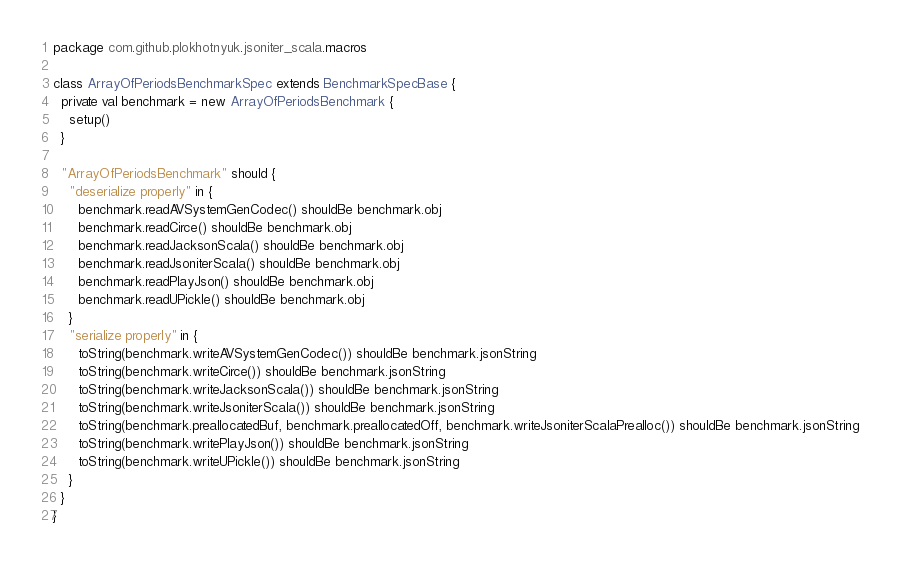<code> <loc_0><loc_0><loc_500><loc_500><_Scala_>package com.github.plokhotnyuk.jsoniter_scala.macros

class ArrayOfPeriodsBenchmarkSpec extends BenchmarkSpecBase {
  private val benchmark = new ArrayOfPeriodsBenchmark {
    setup()
  }
  
  "ArrayOfPeriodsBenchmark" should {
    "deserialize properly" in {
      benchmark.readAVSystemGenCodec() shouldBe benchmark.obj
      benchmark.readCirce() shouldBe benchmark.obj
      benchmark.readJacksonScala() shouldBe benchmark.obj
      benchmark.readJsoniterScala() shouldBe benchmark.obj
      benchmark.readPlayJson() shouldBe benchmark.obj
      benchmark.readUPickle() shouldBe benchmark.obj
    }
    "serialize properly" in {
      toString(benchmark.writeAVSystemGenCodec()) shouldBe benchmark.jsonString
      toString(benchmark.writeCirce()) shouldBe benchmark.jsonString
      toString(benchmark.writeJacksonScala()) shouldBe benchmark.jsonString
      toString(benchmark.writeJsoniterScala()) shouldBe benchmark.jsonString
      toString(benchmark.preallocatedBuf, benchmark.preallocatedOff, benchmark.writeJsoniterScalaPrealloc()) shouldBe benchmark.jsonString
      toString(benchmark.writePlayJson()) shouldBe benchmark.jsonString
      toString(benchmark.writeUPickle()) shouldBe benchmark.jsonString
    }
  }
}</code> 